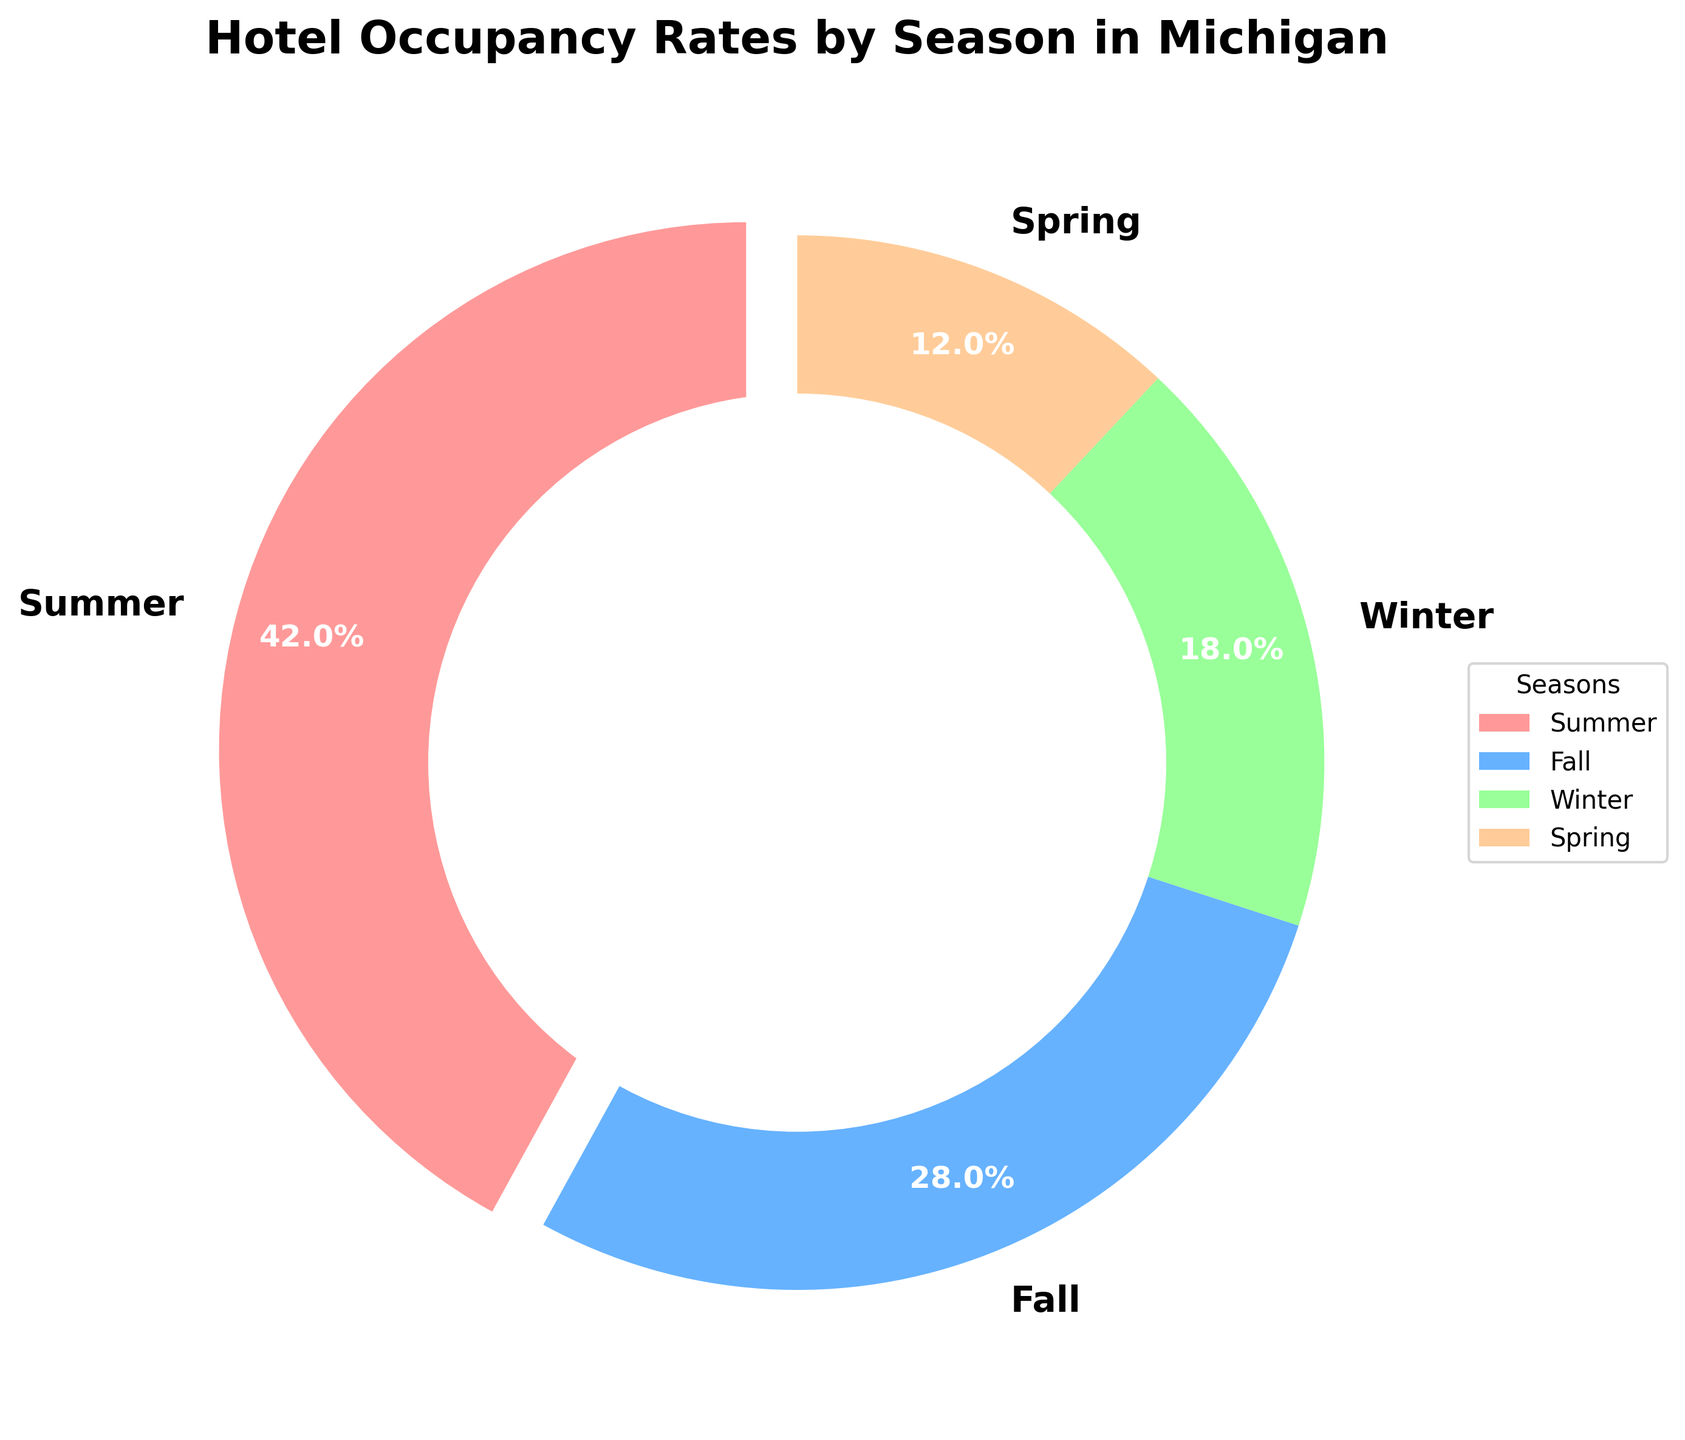What season has the highest hotel occupancy rate? Look at the slices in the pie chart to identify the slice representing the highest occupancy rate. The largest slice corresponds to Summer.
Answer: Summer What is the combined hotel occupancy rate for Winter and Spring? Add the occupancy rates for Winter (18%) and Spring (12%). 18 + 12 = 30
Answer: 30 How much more is the occupancy rate in Fall compared to Spring? Subtract the occupancy rate in Spring (12%) from the occupancy rate in Fall (28%). 28 - 12 = 16
Answer: 16 Which season has the smallest hotel occupancy rate? Look at the slices in the pie chart to identify the smallest slice. The smallest slice corresponds to Spring.
Answer: Spring What is the difference between the occupancy rates in Summer and Winter? Subtract the occupancy rate in Winter (18%) from the occupancy rate in Summer (42%). 42 - 18 = 24
Answer: 24 How do the occupancy rates of Summer and Fall compare? Compare the occupancy rates visually. The occupancy rate for Summer is higher than Fall (42% vs. 28%).
Answer: Summer is higher What percentage of the total occupancy rate does the Spring season represent? Refer to the labeled slice in the pie chart for Spring, which is 12%.
Answer: 12 What is the occupancy rate of the season represented by the blue slice? The blue slice corresponds to Fall. Refer to the labeled slice in the pie chart, which shows 28%.
Answer: 28 How does the occupancy rate in Summer compare to the average rate across all seasons? First, compute the average occupancy rate by summing up the rates and dividing by the number of seasons. (42 + 28 + 18 + 12) / 4 = 25. Summer has an occupancy rate of 42%, which is higher than the average of 25%.
Answer: Higher How much higher is the hotel occupancy rate in Summer compared to Fall? Subtract the occupancy rate in Fall (28%) from Summer (42%). 42 - 28 = 14
Answer: 14 